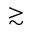Convert formula to latex. <formula><loc_0><loc_0><loc_500><loc_500>\gtrsim</formula> 